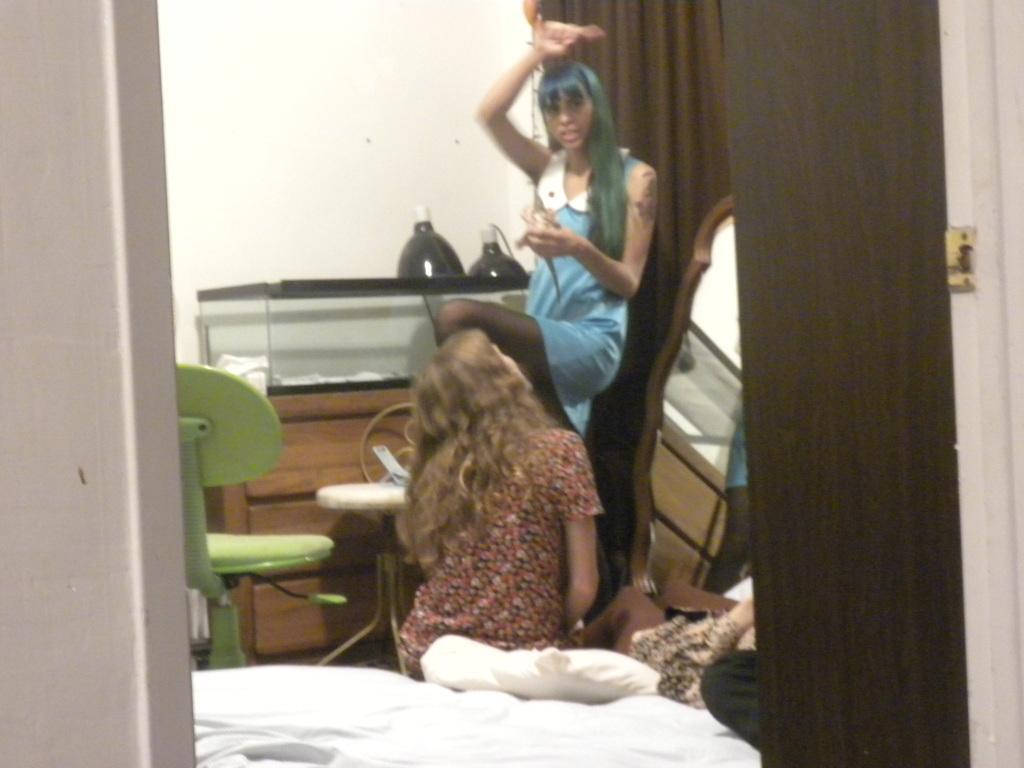Please provide a concise description of this image. In this image I can see one person is standing and an another person is sitting on the bed. I can see the chair, mirror, few objects, curtain, pillow and the wall. 